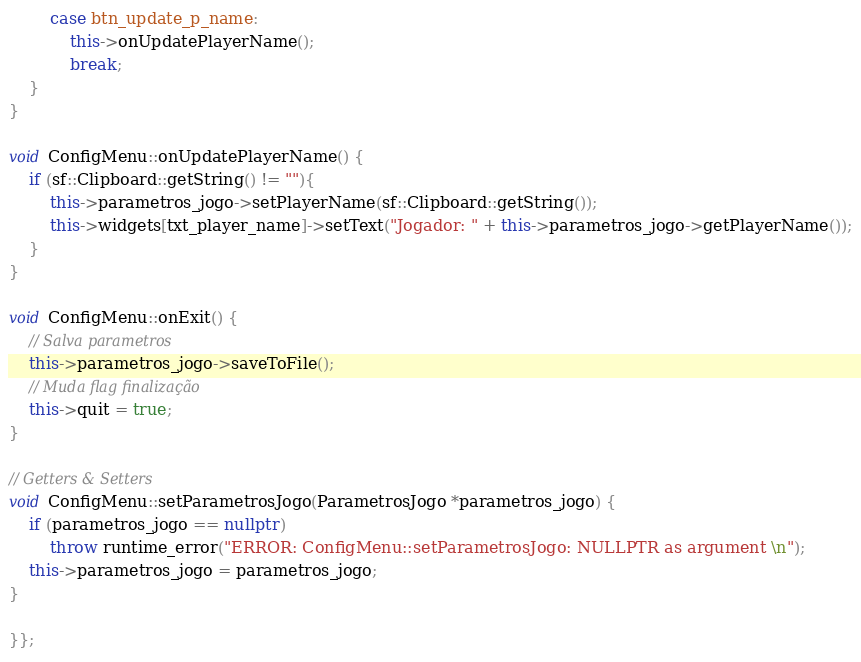<code> <loc_0><loc_0><loc_500><loc_500><_C++_>        case btn_update_p_name:
            this->onUpdatePlayerName();
            break;
    }
}

void ConfigMenu::onUpdatePlayerName() {
    if (sf::Clipboard::getString() != ""){
        this->parametros_jogo->setPlayerName(sf::Clipboard::getString());
        this->widgets[txt_player_name]->setText("Jogador: " + this->parametros_jogo->getPlayerName());
    }
}

void ConfigMenu::onExit() {
    // Salva parametros
    this->parametros_jogo->saveToFile();
    // Muda flag finalização
    this->quit = true;
}

// Getters & Setters
void ConfigMenu::setParametrosJogo(ParametrosJogo *parametros_jogo) {
    if (parametros_jogo == nullptr)
        throw runtime_error("ERROR: ConfigMenu::setParametrosJogo: NULLPTR as argument \n");
    this->parametros_jogo = parametros_jogo;
}

}};
</code> 